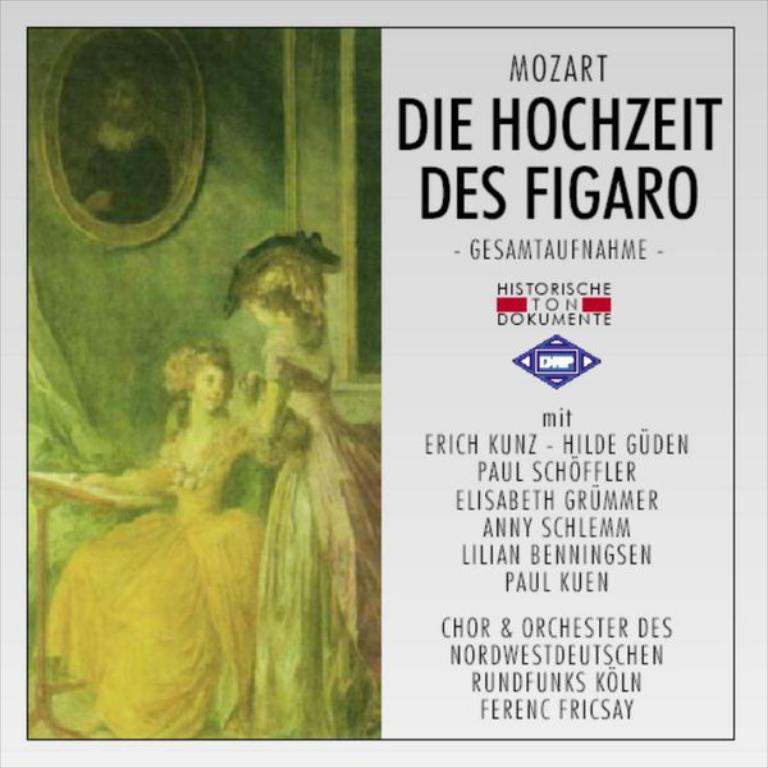<image>
Describe the image concisely. A Mozart album features his interpretation of the Marriage of Figaro. 